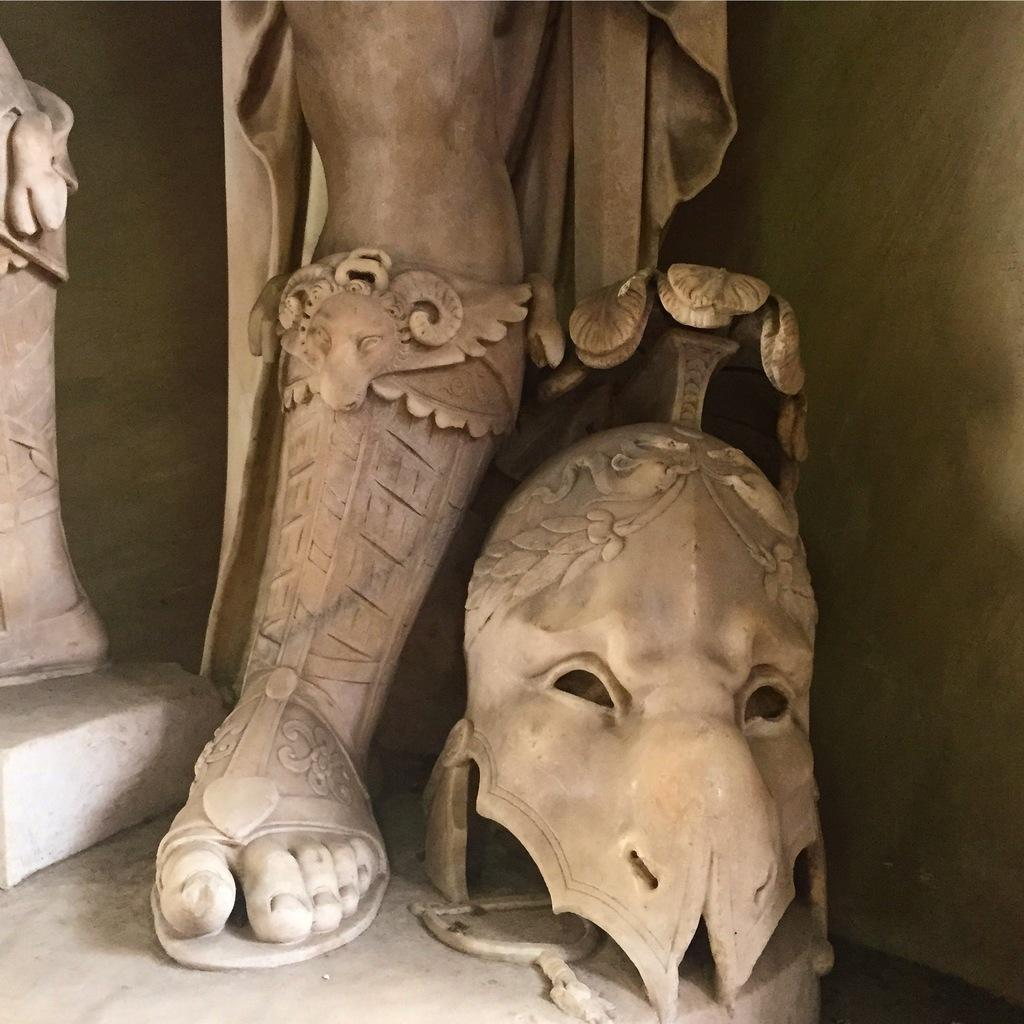What is the main subject in the image? There is a statue in the image. Can you describe any other elements in the image? A person's leg is visible in the image, as well as a helmet. What type of drink is being offered to the statue in the image? There is no drink present in the image; it only features a statue, a person's leg, and a helmet. 